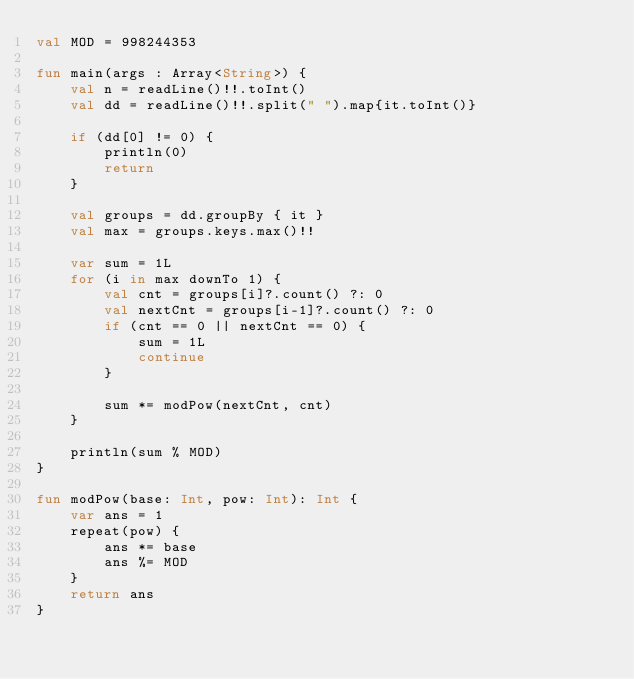Convert code to text. <code><loc_0><loc_0><loc_500><loc_500><_Kotlin_>val MOD = 998244353

fun main(args : Array<String>) {
    val n = readLine()!!.toInt()
    val dd = readLine()!!.split(" ").map{it.toInt()}

    if (dd[0] != 0) {
        println(0)
        return
    }

    val groups = dd.groupBy { it }
    val max = groups.keys.max()!!

    var sum = 1L
    for (i in max downTo 1) {
        val cnt = groups[i]?.count() ?: 0
        val nextCnt = groups[i-1]?.count() ?: 0
        if (cnt == 0 || nextCnt == 0) {
            sum = 1L
            continue
        }

        sum *= modPow(nextCnt, cnt)
    }

    println(sum % MOD)
}

fun modPow(base: Int, pow: Int): Int {
    var ans = 1
    repeat(pow) {
        ans *= base
        ans %= MOD
    }
    return ans
}</code> 